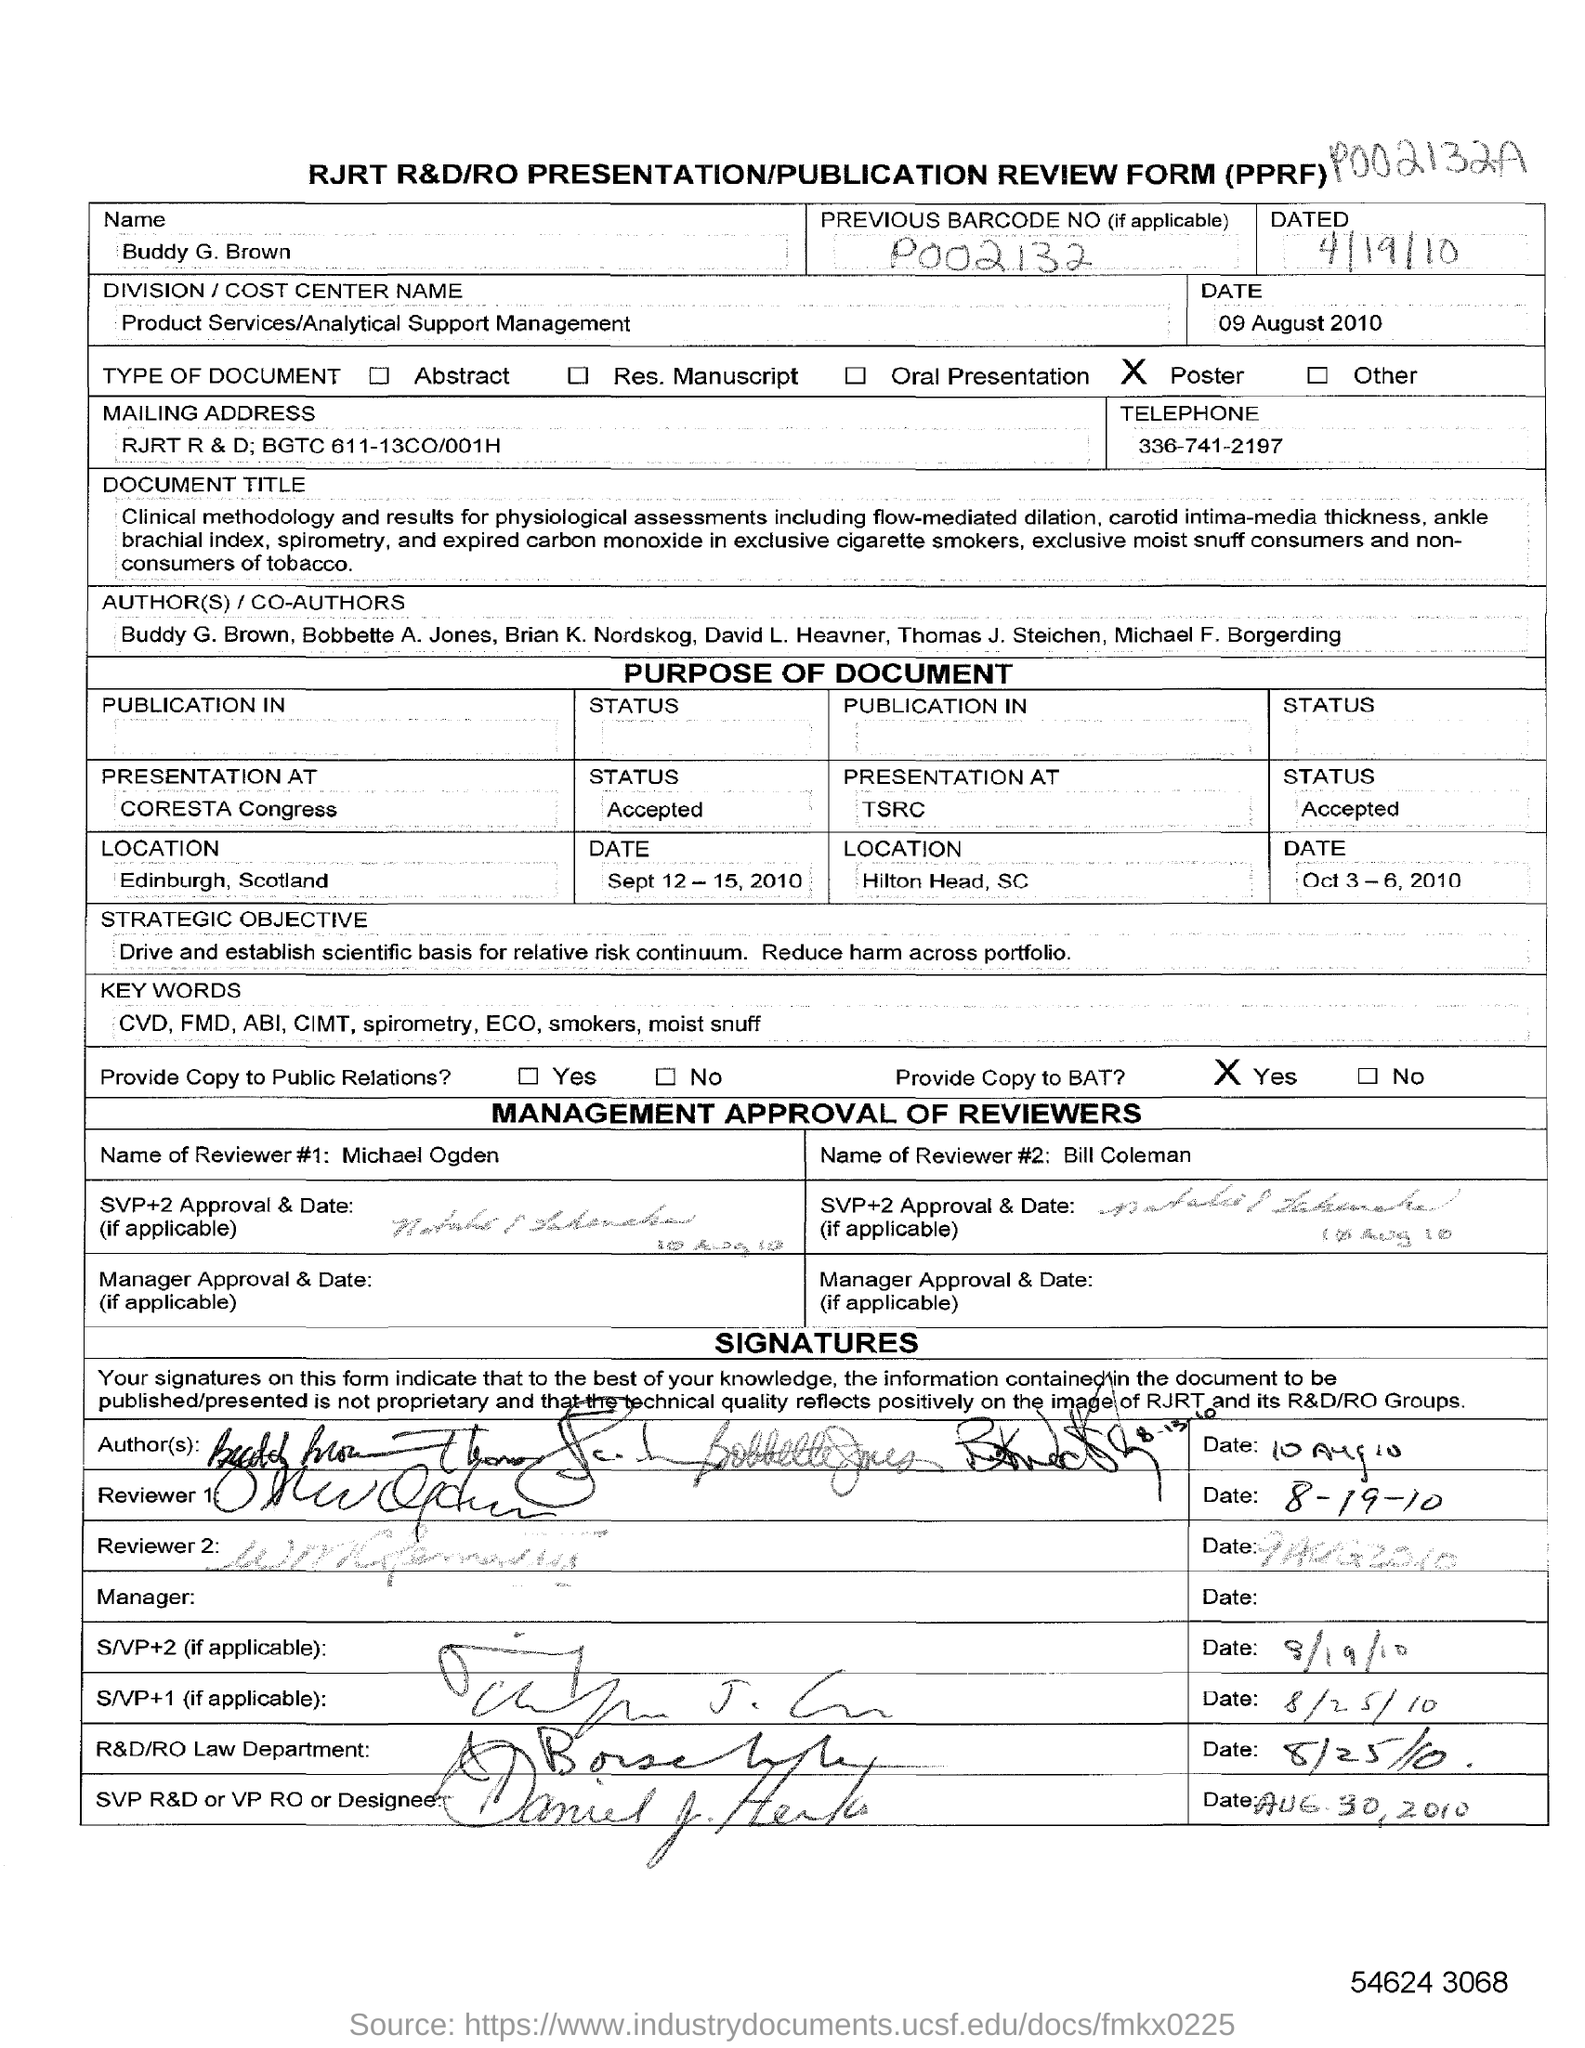What is the fullform of PPRF?
Your response must be concise. PRESENTATION/PUBLICATION REVIEW FORM. What is the name mentioned in the form?
Give a very brief answer. Buddy G. Brown. What is the previous barcode no given in the form?
Give a very brief answer. P002132. What is the division/cost center name given in the form?
Give a very brief answer. Product Services/Analytical Support Management. What is the mailing address given in the form?
Your answer should be compact. RJRT R & D; BGTC 611-13CO/001H. What is the name of reviewer #1 given in the form?
Ensure brevity in your answer.  Michael Ogden. What is the name of reviewer #2 given in the form?
Provide a succinct answer. Bill Coleman. 